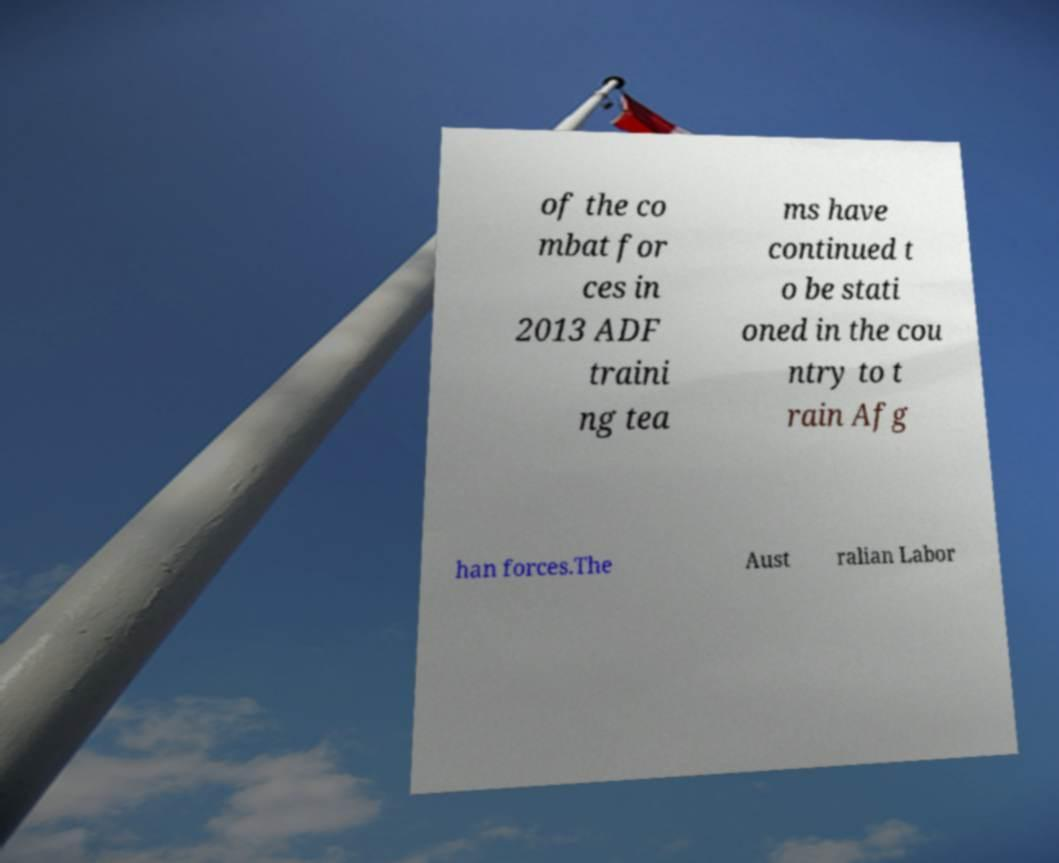Please read and relay the text visible in this image. What does it say? of the co mbat for ces in 2013 ADF traini ng tea ms have continued t o be stati oned in the cou ntry to t rain Afg han forces.The Aust ralian Labor 